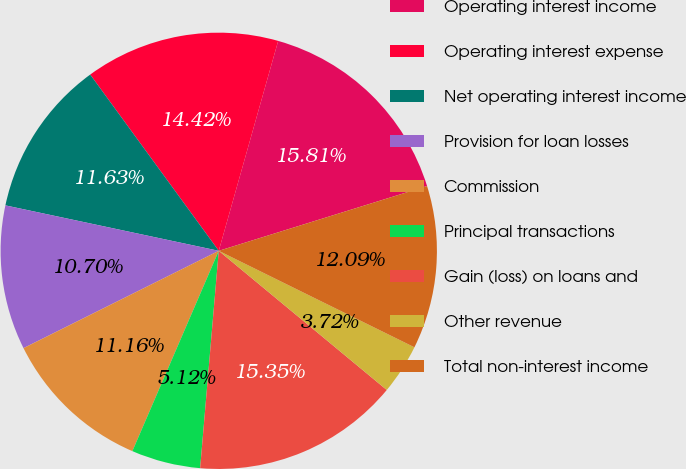Convert chart to OTSL. <chart><loc_0><loc_0><loc_500><loc_500><pie_chart><fcel>Operating interest income<fcel>Operating interest expense<fcel>Net operating interest income<fcel>Provision for loan losses<fcel>Commission<fcel>Principal transactions<fcel>Gain (loss) on loans and<fcel>Other revenue<fcel>Total non-interest income<nl><fcel>15.81%<fcel>14.42%<fcel>11.63%<fcel>10.7%<fcel>11.16%<fcel>5.12%<fcel>15.35%<fcel>3.72%<fcel>12.09%<nl></chart> 